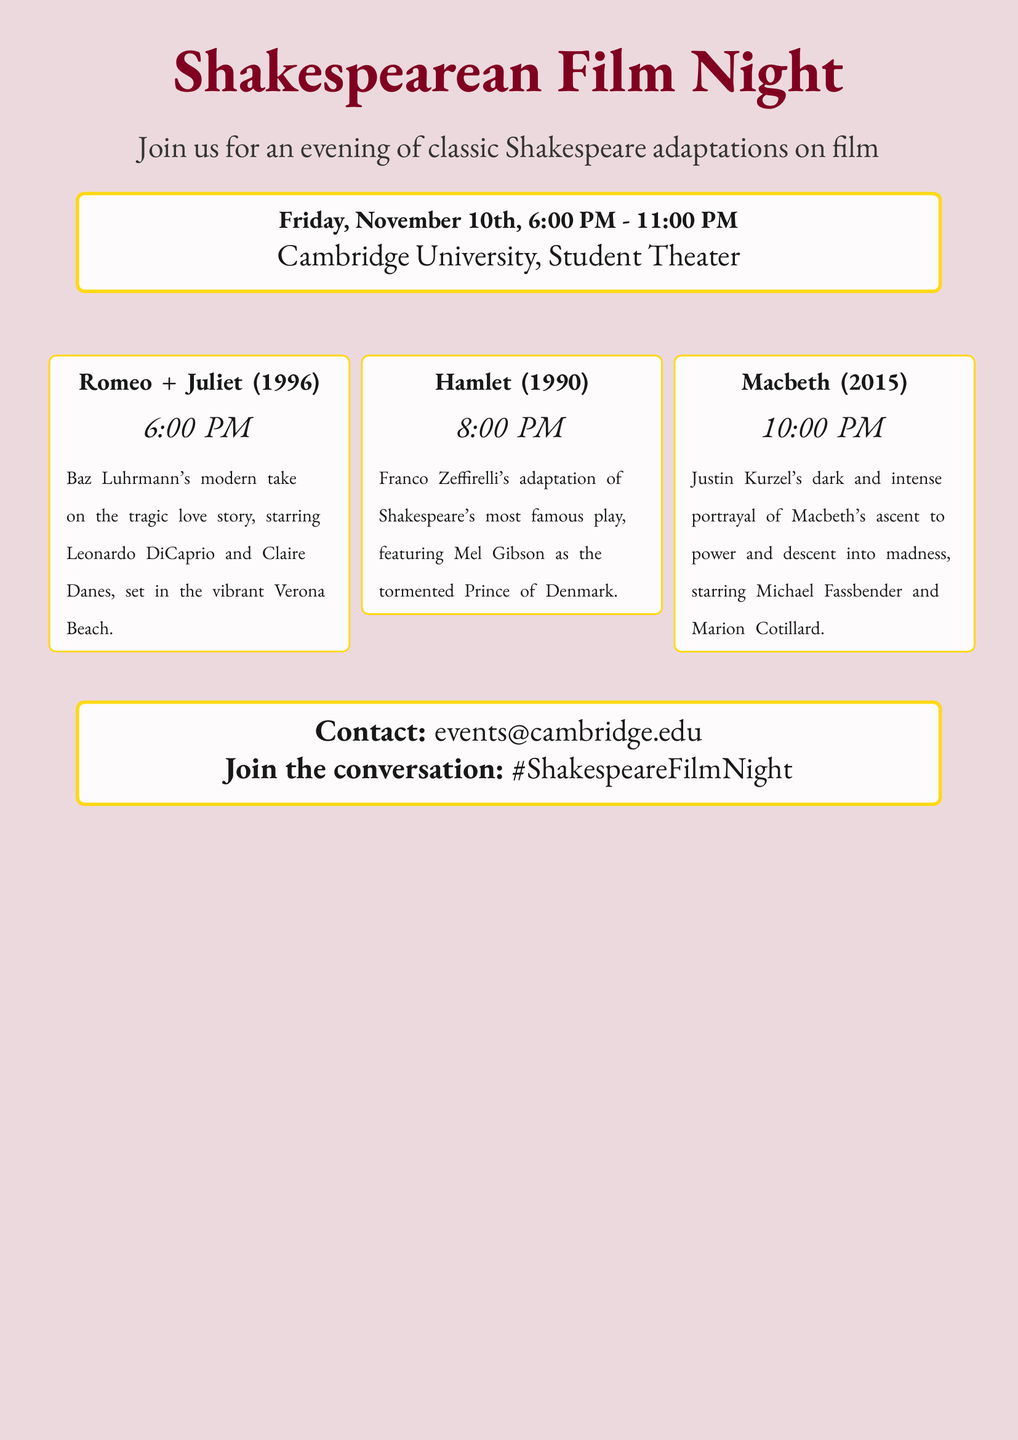What is the title of the event? The title of the event is prominently displayed at the top of the document.
Answer: Shakespearean Film Night When is the event scheduled? The date and time of the event are mentioned in the schedule box.
Answer: Friday, November 10th, 6:00 PM - 11:00 PM Where is the event taking place? The location of the event is provided in the same schedule box.
Answer: Cambridge University, Student Theater What movie is shown at 8:00 PM? The schedule lists the films with their respective showtimes.
Answer: Hamlet (1990) Who stars in the film "Romeo + Juliet"? The synopsis provides information about the lead actors in this adaptation.
Answer: Leonardo DiCaprio and Claire Danes What theme do the films share? The document presents a clear theme as indicated by the title and content.
Answer: Shakespeare adaptations What color represents the background of the flyer? The background color is described at the start of the document.
Answer: curtainred How can attendees join the conversation about the event? The contact information includes a social media hashtag for engagement.
Answer: #ShakespeareFilmNight 